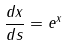<formula> <loc_0><loc_0><loc_500><loc_500>\frac { d x } { d s } = e ^ { x }</formula> 